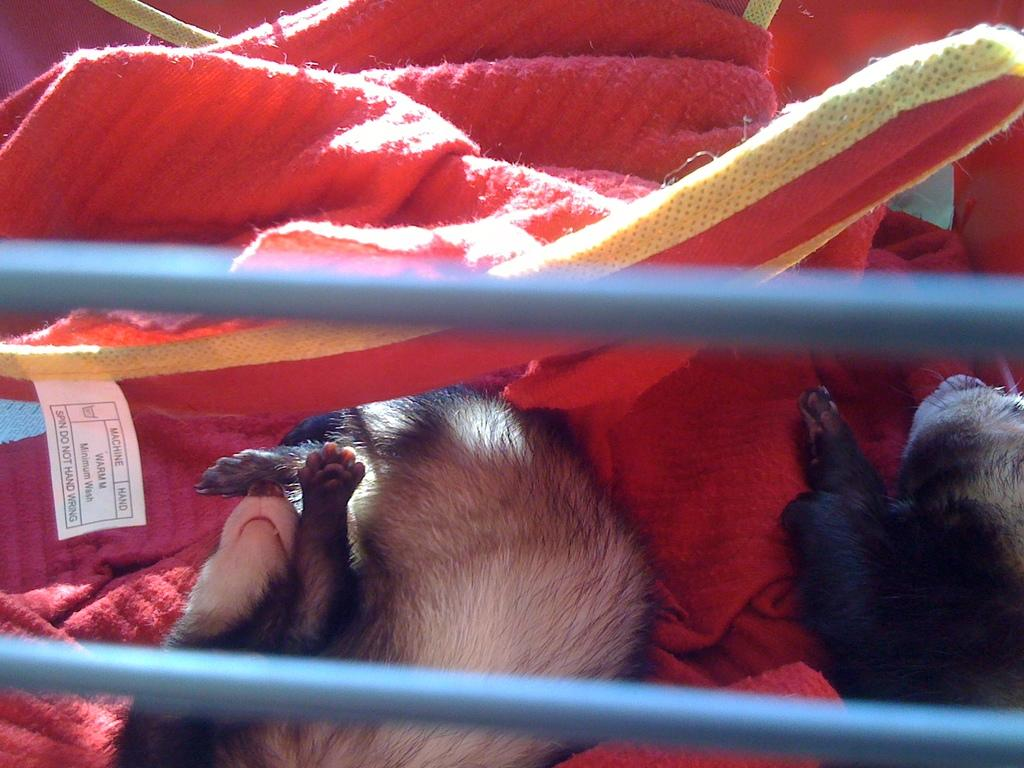What is the focus of the image? The image is zoomed in. What can be seen in the foreground of the image? There are cables in the foreground of the image. What is happening with the animals in the image? There are two animals lying on a red color object. What color cloth is visible in the background of the image? There is a red color cloth visible in the background of the image. What type of flower is being protested against in the image? There is no protest or flower present in the image. What is the cart used for in the image? There is no cart present in the image. 